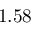Convert formula to latex. <formula><loc_0><loc_0><loc_500><loc_500>1 . 5 8</formula> 